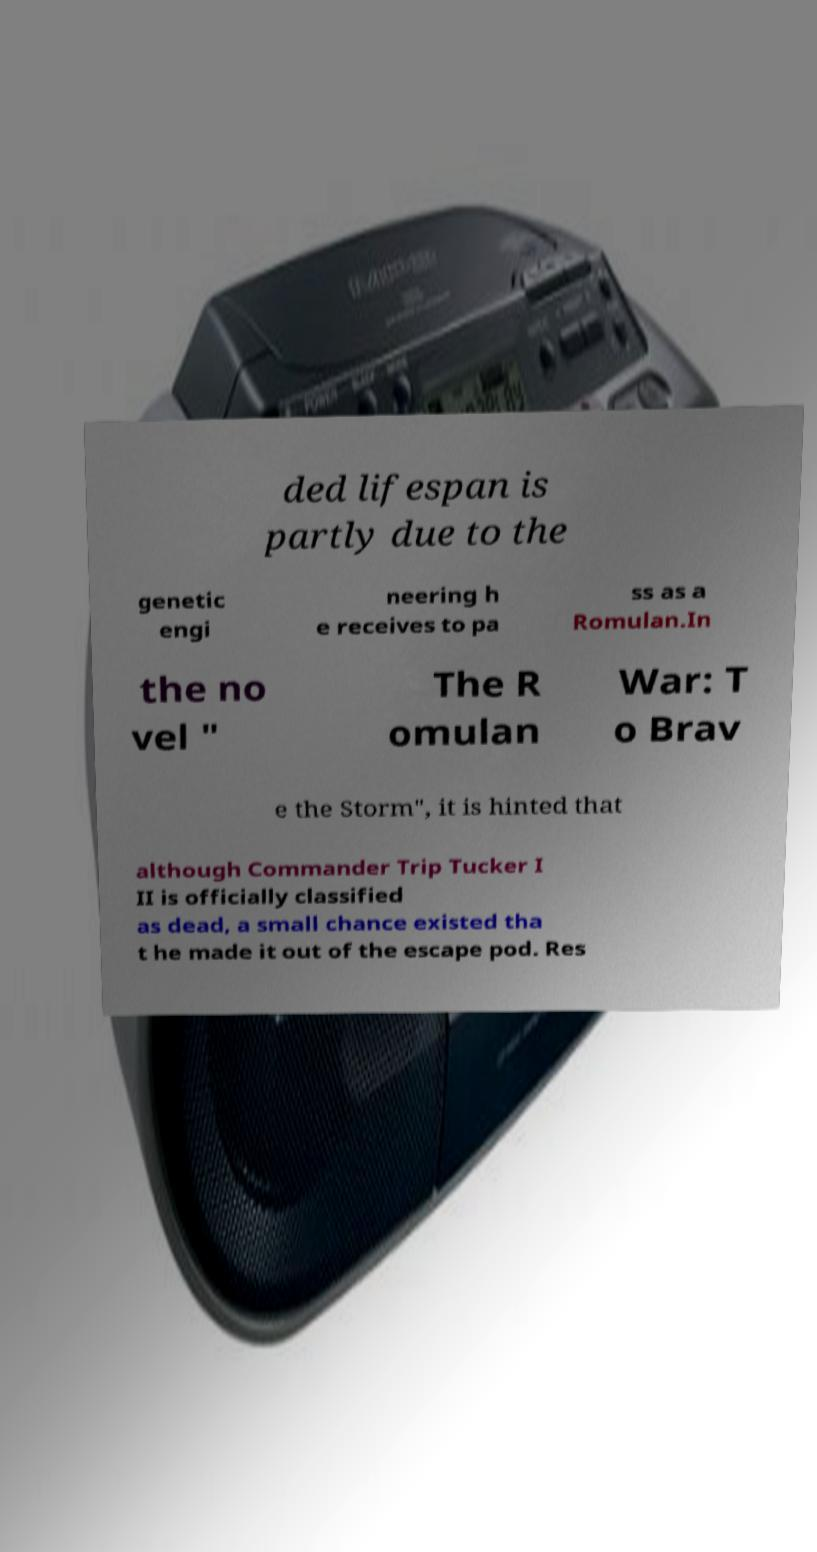Please identify and transcribe the text found in this image. ded lifespan is partly due to the genetic engi neering h e receives to pa ss as a Romulan.In the no vel " The R omulan War: T o Brav e the Storm", it is hinted that although Commander Trip Tucker I II is officially classified as dead, a small chance existed tha t he made it out of the escape pod. Res 